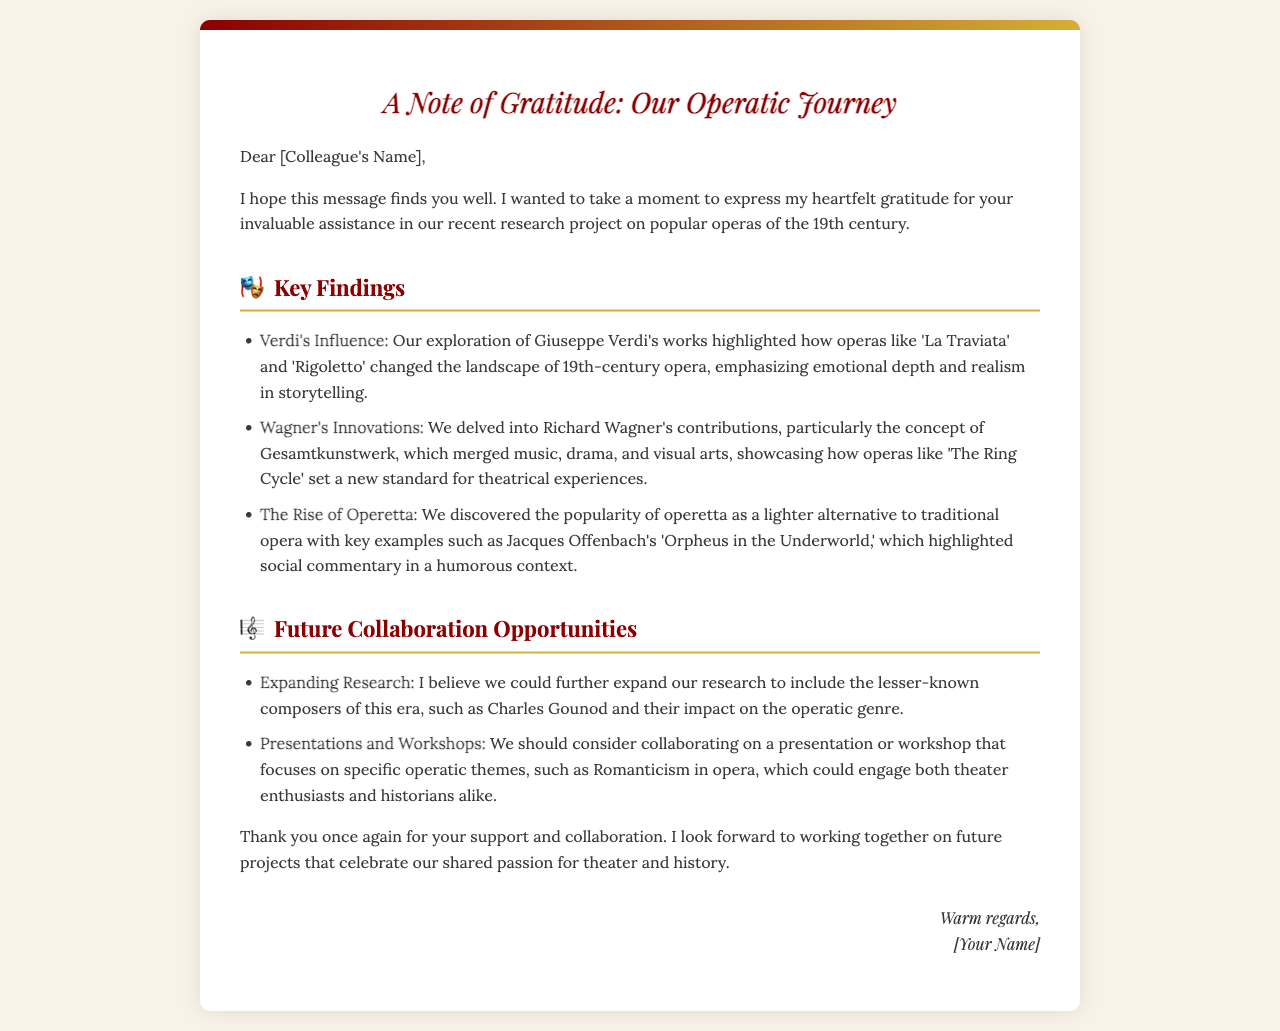what is the title of the letter? The title of the letter is styled prominently at the beginning of the document, which is "A Note of Gratitude: Our Operatic Journey."
Answer: A Note of Gratitude: Our Operatic Journey who is the letter addressed to? The letter opens with "Dear [Colleague's Name]," indicating it is directed to a specific colleague whose name would be included there.
Answer: [Colleague's Name] which composer is noted for works like 'La Traviata' and 'Rigoletto'? In the key findings section, the influence of Giuseppe Verdi is highlighted, specifically mentioning these operas.
Answer: Giuseppe Verdi what concept did Richard Wagner contribute to opera? The document discusses Wagner's innovations, particularly the concept of Gesamtkunstwerk.
Answer: Gesamtkunstwerk what type of operas became popular as a lighter alternative? The letter references the rise of operetta as a lighter alternative to traditional opera.
Answer: Operetta what is one suggested topic for future collaboration? The letter suggests expanding research to include lesser-known composers as a collaboration opportunity.
Answer: Lesser-known composers what is a specific operetta mentioned in the findings? The letter gives an example of Jacques Offenbach's 'Orpheus in the Underworld' in relation to operetta.
Answer: Orpheus in the Underworld who signed the letter? The document concludes with "Warm regards," followed by "[Your Name]," indicating the sender's name would go there.
Answer: [Your Name] 